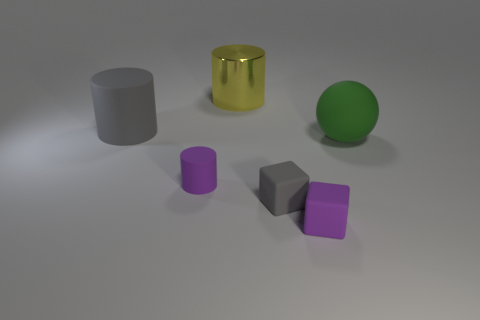Add 1 big green objects. How many objects exist? 7 Subtract all blocks. How many objects are left? 4 Add 6 yellow metallic cylinders. How many yellow metallic cylinders exist? 7 Subtract 0 brown blocks. How many objects are left? 6 Subtract all gray things. Subtract all cylinders. How many objects are left? 1 Add 3 yellow objects. How many yellow objects are left? 4 